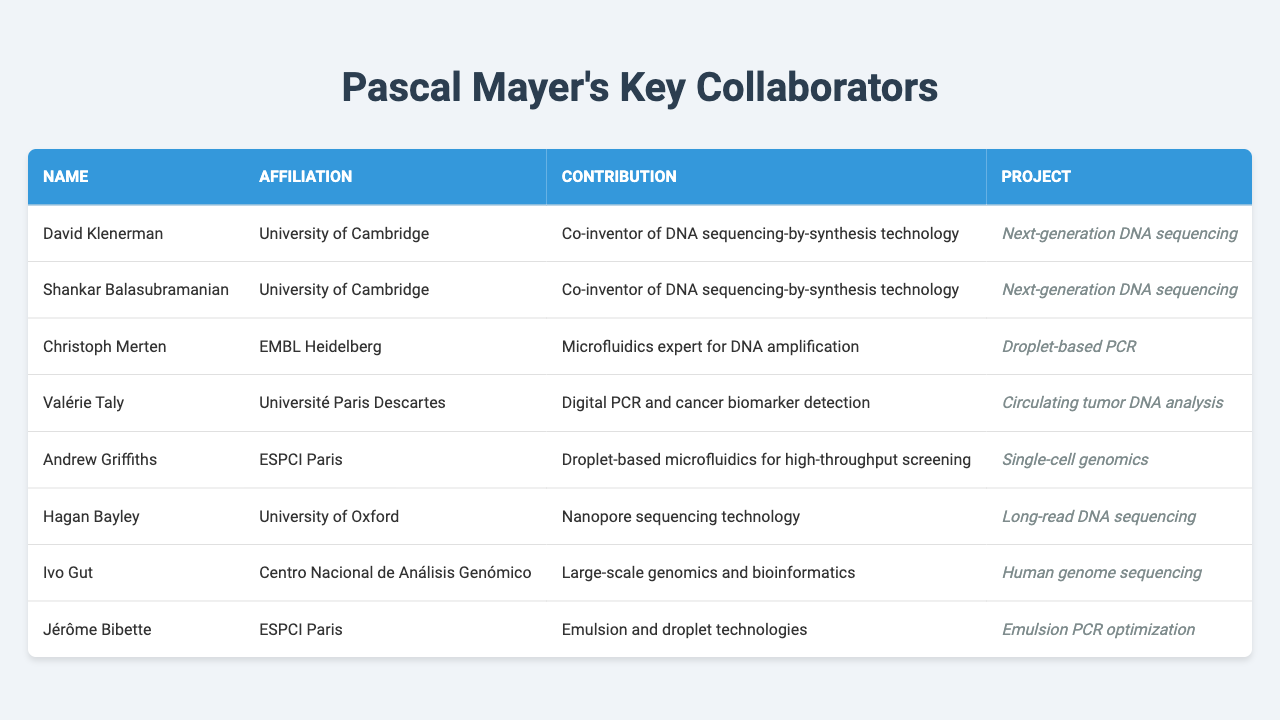What is the affiliation of David Klenerman? The table lists David Klenerman's affiliation as the University of Cambridge.
Answer: University of Cambridge How many collaborators are affiliated with the University of Cambridge? There are 2 collaborators from the University of Cambridge: David Klenerman and Shankar Balasubramanian.
Answer: 2 Who contributed to the project on circulating tumor DNA analysis? The collaborator Valérie Taly is listed as contributing to the project on circulating tumor DNA analysis.
Answer: Valérie Taly Can you name a collaborator who worked on long-read DNA sequencing? Hagan Bayley is named as a collaborator who worked on long-read DNA sequencing.
Answer: Hagan Bayley Is Ivo Gut involved in the single-cell genomics project? No, Ivo Gut is involved in the human genome sequencing project, not single-cell genomics.
Answer: No Which collaborator has expertise in emulsion and droplet technologies? Jérôme Bibette is the collaborator who has expertise in emulsion and droplet technologies.
Answer: Jérôme Bibette What is the common technology that David Klenerman and Shankar Balasubramanian co-invented? They both co-invented DNA sequencing-by-synthesis technology.
Answer: DNA sequencing-by-synthesis technology How many projects listed involve DNA sequencing? There are 4 projects listed involving DNA sequencing: Next-generation DNA sequencing, Long-read DNA sequencing, Circulating tumor DNA analysis, and Human genome sequencing.
Answer: 4 Which collaborator is responsible for digital PCR? Valérie Taly is responsible for digital PCR and cancer biomarker detection in her project.
Answer: Valérie Taly Which collaborator has a contribution related to microfluidics? Andrew Griffiths is noted for droplet-based microfluidics for high-throughput screening, indicating his contribution is related to microfluidics.
Answer: Andrew Griffiths Who among the collaborators is affiliated with EMBL Heidelberg? Christoph Merten is the collaborator affiliated with EMBL Heidelberg.
Answer: Christoph Merten Do any collaborations focus specifically on cancer research? Yes, Valérie Taly's contribution relates to cancer biomarker detection in the context of circulating tumor DNA analysis, indicating a focus on cancer research.
Answer: Yes Which project has contributions from two collaborators affiliated with the same institution? The project "Next-generation DNA sequencing" has contributions from two collaborators, David Klenerman and Shankar Balasubramanian, both affiliated with the University of Cambridge.
Answer: Next-generation DNA sequencing Which collaborator is involved in the optimization of emulsion PCR? Jérôme Bibette is involved in optimizing emulsion PCR, as stated in his contribution.
Answer: Jérôme Bibette If you were to summarize the contributions to human genome sequencing, which collaborator would you mention? Ivo Gut is the collaborator mentioned for his contribution to large-scale genomics and bioinformatics in the human genome sequencing project.
Answer: Ivo Gut 